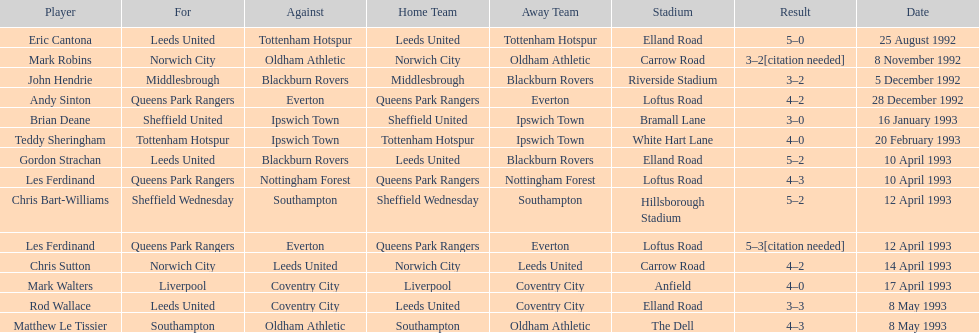Which team did liverpool go up against? Coventry City. Write the full table. {'header': ['Player', 'For', 'Against', 'Home Team', 'Away Team', 'Stadium', 'Result', 'Date'], 'rows': [['Eric Cantona', 'Leeds United', 'Tottenham Hotspur', 'Leeds United', 'Tottenham Hotspur', 'Elland Road', '5–0', '25 August 1992'], ['Mark Robins', 'Norwich City', 'Oldham Athletic', 'Norwich City', 'Oldham Athletic', 'Carrow Road', '3–2[citation needed]', '8 November 1992'], ['John Hendrie', 'Middlesbrough', 'Blackburn Rovers', 'Middlesbrough', 'Blackburn Rovers', 'Riverside Stadium', '3–2', '5 December 1992'], ['Andy Sinton', 'Queens Park Rangers', 'Everton', 'Queens Park Rangers', 'Everton', 'Loftus Road', '4–2', '28 December 1992'], ['Brian Deane', 'Sheffield United', 'Ipswich Town', 'Sheffield United', 'Ipswich Town', 'Bramall Lane', '3–0', '16 January 1993'], ['Teddy Sheringham', 'Tottenham Hotspur', 'Ipswich Town', 'Tottenham Hotspur', 'Ipswich Town', 'White Hart Lane', '4–0', '20 February 1993'], ['Gordon Strachan', 'Leeds United', 'Blackburn Rovers', 'Leeds United', 'Blackburn Rovers', 'Elland Road', '5–2', '10 April 1993'], ['Les Ferdinand', 'Queens Park Rangers', 'Nottingham Forest', 'Queens Park Rangers', 'Nottingham Forest', 'Loftus Road', '4–3', '10 April 1993'], ['Chris Bart-Williams', 'Sheffield Wednesday', 'Southampton', 'Sheffield Wednesday', 'Southampton', 'Hillsborough Stadium', '5–2', '12 April 1993'], ['Les Ferdinand', 'Queens Park Rangers', 'Everton', 'Queens Park Rangers', 'Everton', 'Loftus Road', '5–3[citation needed]', '12 April 1993'], ['Chris Sutton', 'Norwich City', 'Leeds United', 'Norwich City', 'Leeds United', 'Carrow Road', '4–2', '14 April 1993'], ['Mark Walters', 'Liverpool', 'Coventry City', 'Liverpool', 'Coventry City', 'Anfield', '4–0', '17 April 1993'], ['Rod Wallace', 'Leeds United', 'Coventry City', 'Leeds United', 'Coventry City', 'Elland Road', '3–3', '8 May 1993'], ['Matthew Le Tissier', 'Southampton', 'Oldham Athletic', 'Southampton', 'Oldham Athletic', 'The Dell', '4–3', '8 May 1993']]} 